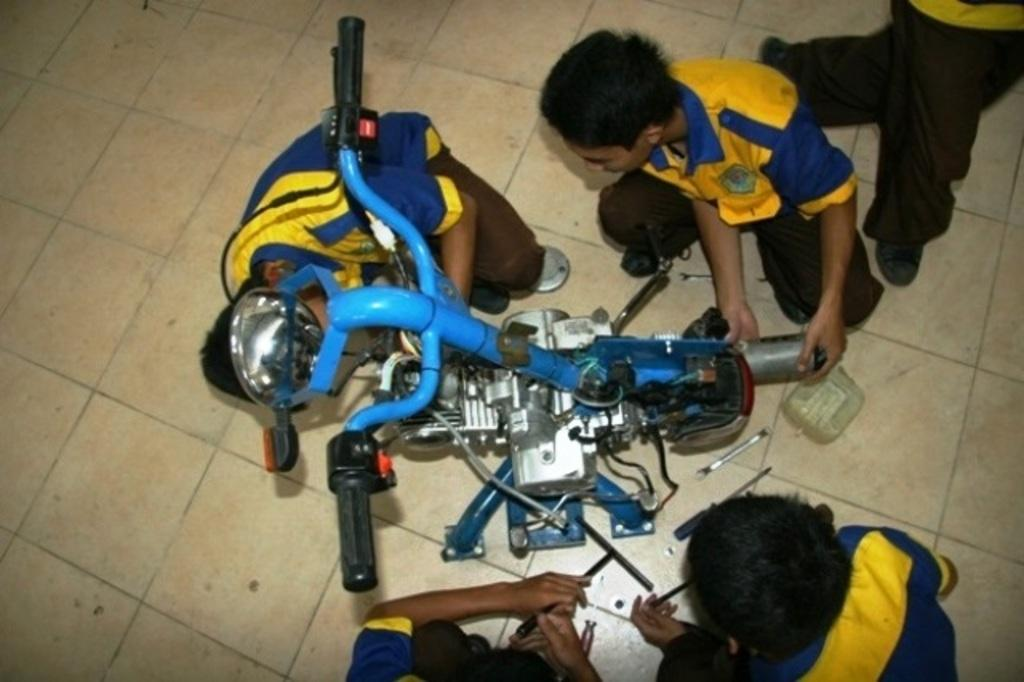What are the people in the image doing? The people in the image are sitting on the ground. What else can be seen in the image besides the people? There is a motor vehicle in the image. What type of dogs are performing with the band in the image? There is no band or dogs present in the image; it only features people sitting on the ground and a motor vehicle. 